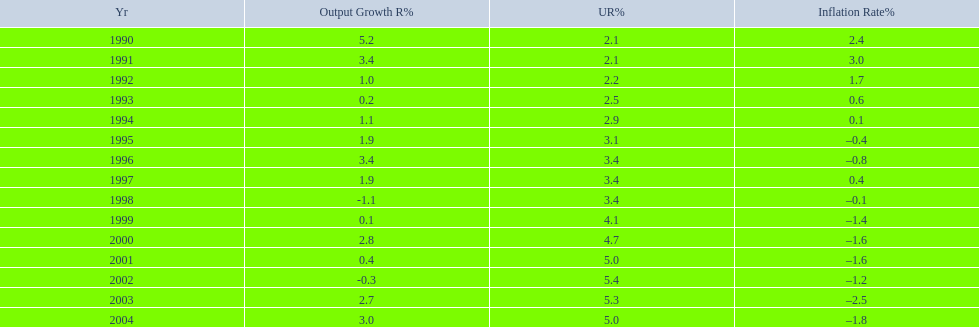Were the highest unemployment rates in japan before or after the year 2000? After. 